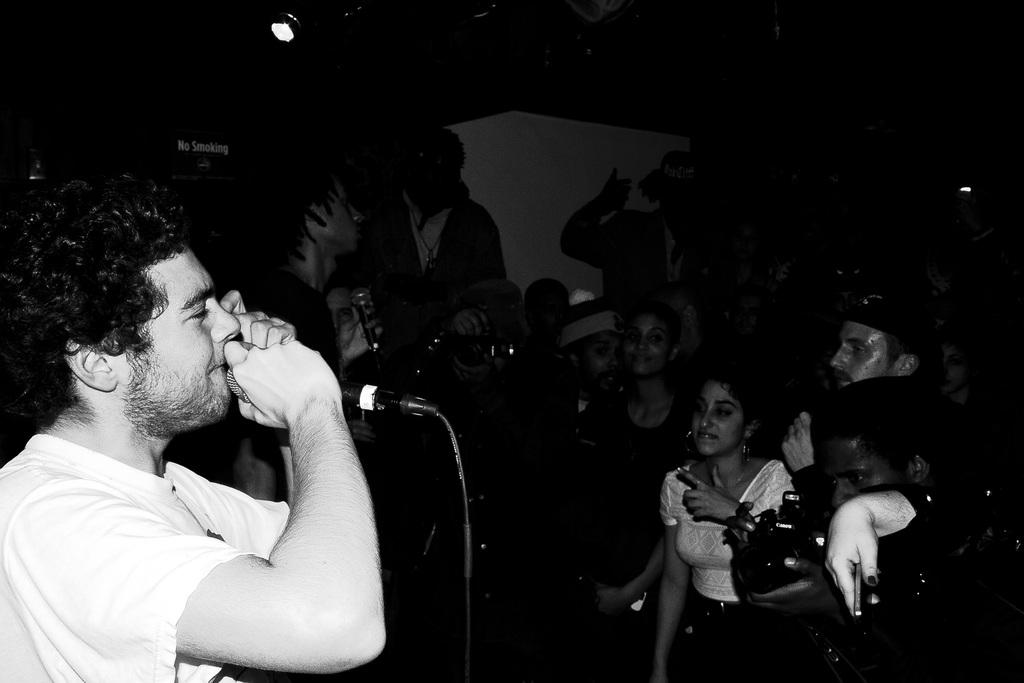What is the man in the image holding? The man in the image is holding a mic. How many people are present in the image? There are multiple people in the image. What are some of the people doing in the image? Some of the people are holding cameras. Are there any other people holding mics in the image? Yes, there is another person holding a mic in the image. What type of pail is being used to collect water in the image? There is no pail present in the image; it features a man holding a mic and multiple people holding cameras. What do the people in the image believe about the importance of photography? The image does not provide any information about the beliefs of the people in the image. 